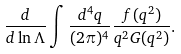<formula> <loc_0><loc_0><loc_500><loc_500>\frac { d } { d \ln \Lambda } \int \frac { d ^ { 4 } q } { ( 2 \pi ) ^ { 4 } } \frac { f ( q ^ { 2 } ) } { q ^ { 2 } G ( q ^ { 2 } ) } .</formula> 